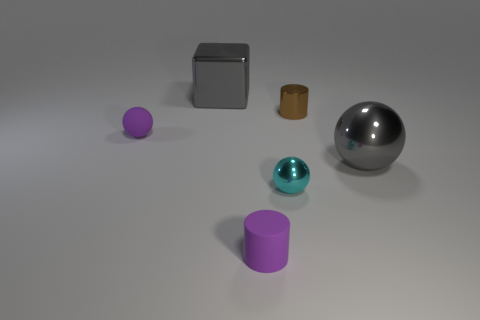There is a thing that is the same color as the tiny rubber ball; what is its material?
Offer a terse response. Rubber. Are the large gray object that is in front of the tiny brown metal object and the gray thing that is behind the tiny brown metallic cylinder made of the same material?
Ensure brevity in your answer.  Yes. Are there more small rubber objects than purple cylinders?
Provide a short and direct response. Yes. What color is the big object behind the small purple thing that is behind the large shiny thing that is right of the tiny purple matte cylinder?
Your response must be concise. Gray. Do the tiny thing that is on the left side of the purple rubber cylinder and the cylinder that is in front of the gray metallic ball have the same color?
Your response must be concise. Yes. There is a small rubber thing that is behind the gray metal sphere; what number of brown objects are behind it?
Ensure brevity in your answer.  1. Is there a large yellow ball?
Your answer should be compact. No. How many other objects are there of the same color as the small metallic ball?
Provide a succinct answer. 0. Is the number of purple objects less than the number of metallic objects?
Provide a short and direct response. Yes. What shape is the purple thing that is behind the gray metal thing that is in front of the big block?
Make the answer very short. Sphere. 